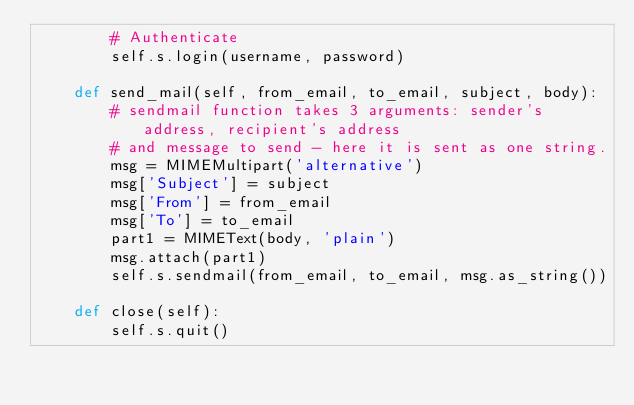Convert code to text. <code><loc_0><loc_0><loc_500><loc_500><_Python_>        # Authenticate
        self.s.login(username, password)
 
    def send_mail(self, from_email, to_email, subject, body):
        # sendmail function takes 3 arguments: sender's address, recipient's address
        # and message to send - here it is sent as one string.
        msg = MIMEMultipart('alternative')
        msg['Subject'] = subject
        msg['From'] = from_email
        msg['To'] = to_email
        part1 = MIMEText(body, 'plain')
        msg.attach(part1)
        self.s.sendmail(from_email, to_email, msg.as_string())

    def close(self):
        self.s.quit()
</code> 